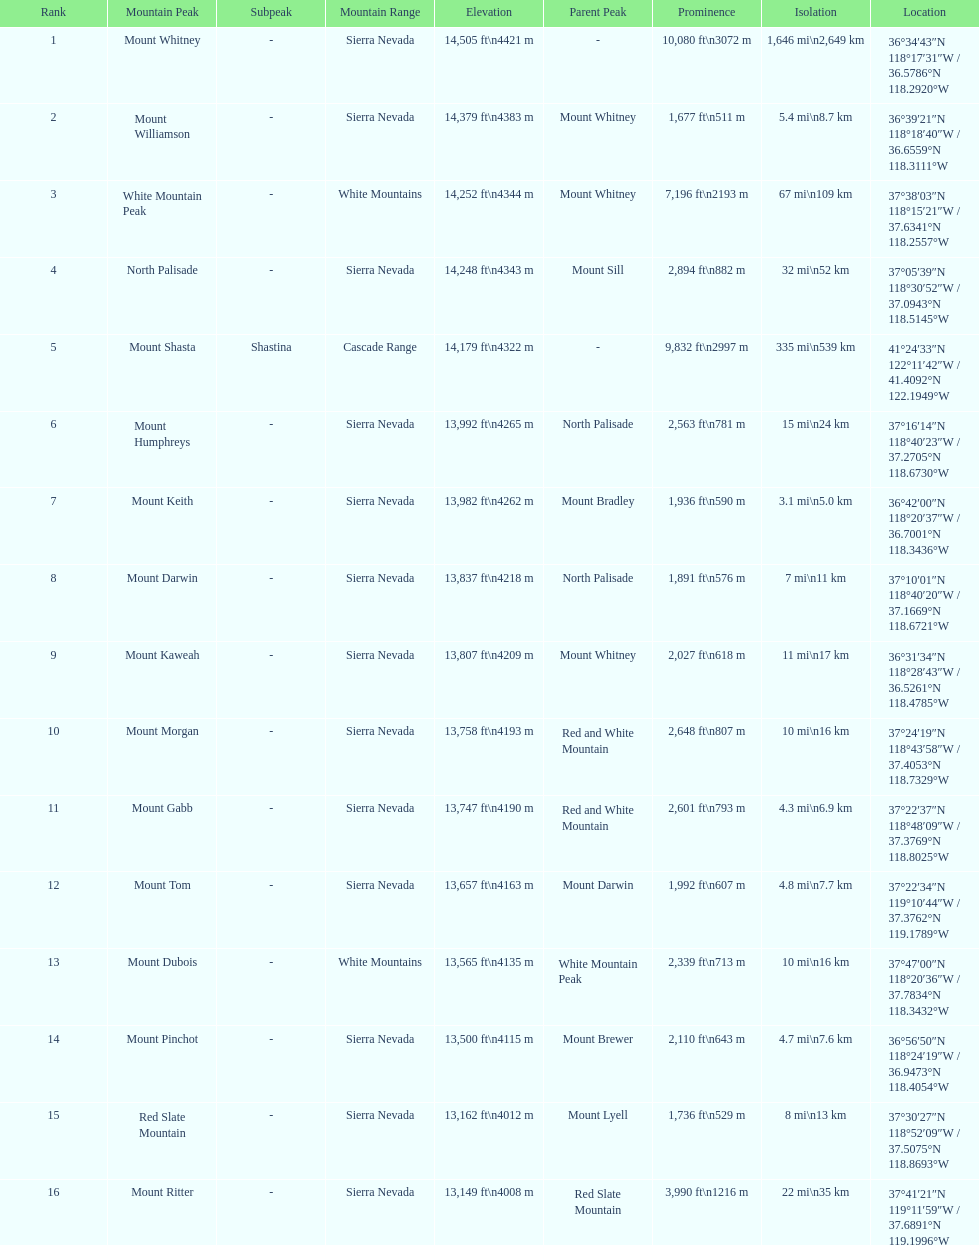Which mountain peak has a prominence more than 10,000 ft? Mount Whitney. Can you parse all the data within this table? {'header': ['Rank', 'Mountain Peak', 'Subpeak', 'Mountain Range', 'Elevation', 'Parent Peak', 'Prominence', 'Isolation', 'Location'], 'rows': [['1', 'Mount Whitney', '-', 'Sierra Nevada', '14,505\xa0ft\\n4421\xa0m', '-', '10,080\xa0ft\\n3072\xa0m', '1,646\xa0mi\\n2,649\xa0km', '36°34′43″N 118°17′31″W\ufeff / \ufeff36.5786°N 118.2920°W'], ['2', 'Mount Williamson', '-', 'Sierra Nevada', '14,379\xa0ft\\n4383\xa0m', 'Mount Whitney', '1,677\xa0ft\\n511\xa0m', '5.4\xa0mi\\n8.7\xa0km', '36°39′21″N 118°18′40″W\ufeff / \ufeff36.6559°N 118.3111°W'], ['3', 'White Mountain Peak', '-', 'White Mountains', '14,252\xa0ft\\n4344\xa0m', 'Mount Whitney', '7,196\xa0ft\\n2193\xa0m', '67\xa0mi\\n109\xa0km', '37°38′03″N 118°15′21″W\ufeff / \ufeff37.6341°N 118.2557°W'], ['4', 'North Palisade', '-', 'Sierra Nevada', '14,248\xa0ft\\n4343\xa0m', 'Mount Sill', '2,894\xa0ft\\n882\xa0m', '32\xa0mi\\n52\xa0km', '37°05′39″N 118°30′52″W\ufeff / \ufeff37.0943°N 118.5145°W'], ['5', 'Mount Shasta', 'Shastina', 'Cascade Range', '14,179\xa0ft\\n4322\xa0m', '-', '9,832\xa0ft\\n2997\xa0m', '335\xa0mi\\n539\xa0km', '41°24′33″N 122°11′42″W\ufeff / \ufeff41.4092°N 122.1949°W'], ['6', 'Mount Humphreys', '-', 'Sierra Nevada', '13,992\xa0ft\\n4265\xa0m', 'North Palisade', '2,563\xa0ft\\n781\xa0m', '15\xa0mi\\n24\xa0km', '37°16′14″N 118°40′23″W\ufeff / \ufeff37.2705°N 118.6730°W'], ['7', 'Mount Keith', '-', 'Sierra Nevada', '13,982\xa0ft\\n4262\xa0m', 'Mount Bradley', '1,936\xa0ft\\n590\xa0m', '3.1\xa0mi\\n5.0\xa0km', '36°42′00″N 118°20′37″W\ufeff / \ufeff36.7001°N 118.3436°W'], ['8', 'Mount Darwin', '-', 'Sierra Nevada', '13,837\xa0ft\\n4218\xa0m', 'North Palisade', '1,891\xa0ft\\n576\xa0m', '7\xa0mi\\n11\xa0km', '37°10′01″N 118°40′20″W\ufeff / \ufeff37.1669°N 118.6721°W'], ['9', 'Mount Kaweah', '-', 'Sierra Nevada', '13,807\xa0ft\\n4209\xa0m', 'Mount Whitney', '2,027\xa0ft\\n618\xa0m', '11\xa0mi\\n17\xa0km', '36°31′34″N 118°28′43″W\ufeff / \ufeff36.5261°N 118.4785°W'], ['10', 'Mount Morgan', '-', 'Sierra Nevada', '13,758\xa0ft\\n4193\xa0m', 'Red and White Mountain', '2,648\xa0ft\\n807\xa0m', '10\xa0mi\\n16\xa0km', '37°24′19″N 118°43′58″W\ufeff / \ufeff37.4053°N 118.7329°W'], ['11', 'Mount Gabb', '-', 'Sierra Nevada', '13,747\xa0ft\\n4190\xa0m', 'Red and White Mountain', '2,601\xa0ft\\n793\xa0m', '4.3\xa0mi\\n6.9\xa0km', '37°22′37″N 118°48′09″W\ufeff / \ufeff37.3769°N 118.8025°W'], ['12', 'Mount Tom', '-', 'Sierra Nevada', '13,657\xa0ft\\n4163\xa0m', 'Mount Darwin', '1,992\xa0ft\\n607\xa0m', '4.8\xa0mi\\n7.7\xa0km', '37°22′34″N 119°10′44″W\ufeff / \ufeff37.3762°N 119.1789°W'], ['13', 'Mount Dubois', '-', 'White Mountains', '13,565\xa0ft\\n4135\xa0m', 'White Mountain Peak', '2,339\xa0ft\\n713\xa0m', '10\xa0mi\\n16\xa0km', '37°47′00″N 118°20′36″W\ufeff / \ufeff37.7834°N 118.3432°W'], ['14', 'Mount Pinchot', '-', 'Sierra Nevada', '13,500\xa0ft\\n4115\xa0m', 'Mount Brewer', '2,110\xa0ft\\n643\xa0m', '4.7\xa0mi\\n7.6\xa0km', '36°56′50″N 118°24′19″W\ufeff / \ufeff36.9473°N 118.4054°W'], ['15', 'Red Slate Mountain', '-', 'Sierra Nevada', '13,162\xa0ft\\n4012\xa0m', 'Mount Lyell', '1,736\xa0ft\\n529\xa0m', '8\xa0mi\\n13\xa0km', '37°30′27″N 118°52′09″W\ufeff / \ufeff37.5075°N 118.8693°W'], ['16', 'Mount Ritter', '-', 'Sierra Nevada', '13,149\xa0ft\\n4008\xa0m', 'Red Slate Mountain', '3,990\xa0ft\\n1216\xa0m', '22\xa0mi\\n35\xa0km', '37°41′21″N 119°11′59″W\ufeff / \ufeff37.6891°N 119.1996°W']]} 